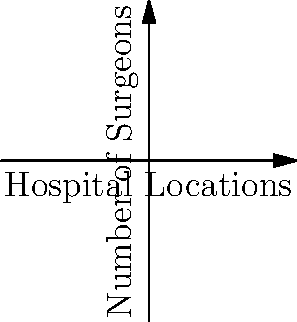Given the graph representing the distribution of surgeons across four hospital locations (A, B, C, and D), determine the optimal redistribution of surgeons to minimize the maximum difference in surgeon count between any two locations while maintaining the total number of surgeons. What is the minimum achievable maximum difference? To solve this problem, we'll follow these steps:

1. Calculate the total number of surgeons:
   A: 5, B: 8, C: 3, D: 6
   Total = 5 + 8 + 3 + 6 = 22 surgeons

2. Calculate the ideal equal distribution:
   22 surgeons ÷ 4 locations = 5.5 surgeons per location

3. Since we can't have fractional surgeons, we need to distribute them as evenly as possible:
   - Two locations will have 5 surgeons
   - Two locations will have 6 surgeons

4. Current maximum difference: 8 - 3 = 5

5. Optimal redistribution:
   - Move 2 surgeons from B to C
   - Move 1 surgeon from B to A or D

6. New distribution:
   A: 5 or 6, B: 5, C: 5, D: 6 or 5

7. Calculate the new maximum difference:
   6 - 5 = 1

Therefore, the minimum achievable maximum difference is 1 surgeon between any two locations.
Answer: 1 surgeon 